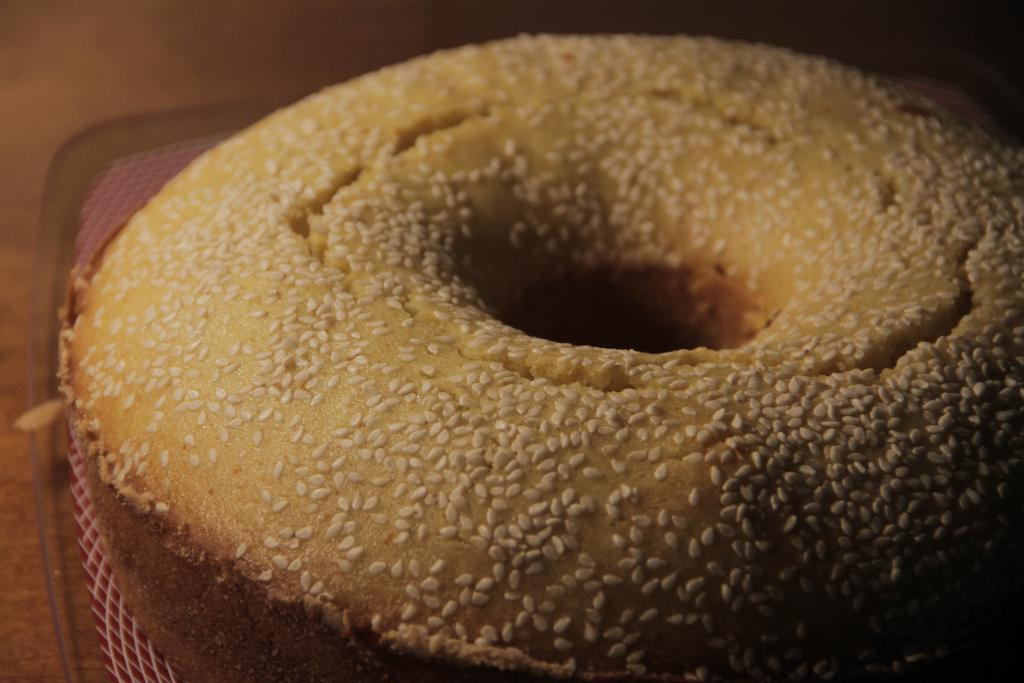What type of food is in the image? There is a doughnut in the image. What can be seen on the surface of the doughnut? The doughnut has white sesame seeds on it. On what is the doughnut placed? The doughnut is placed on a cloth. What is the cloth placed on? The cloth is placed on a plate. What is the plate placed on? The plate is placed on a wooden table. How does the wind affect the doughnut in the image? There is no wind present in the image, so it does not affect the doughnut. 